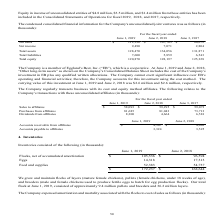According to Cal Maine Foods's financial document, What is the number of eggs in 2019? According to the financial document, 14,318 (in thousands). The relevant text states: "accumulated amortization $ 105,536 $ 96,594 Eggs 14,318 17,313 Feed and supplies 52,383 54,737 $ 172,237 $ 168,644..." Also, can you calculate: What is the increase / (decrease) in number of eggs in 2019? Based on the calculation: 14,318 - 17,313, the result is -2995 (in thousands). This is based on the information: "lated amortization $ 105,536 $ 96,594 Eggs 14,318 17,313 Feed and supplies 52,383 54,737 $ 172,237 $ 168,644 accumulated amortization $ 105,536 $ 96,594 Eggs 14,318 17,313 Feed and supplies 52,383 54,..." The key data points involved are: 14,318, 17,313. Also, What was the flock composition in June 2019? consisted of approximately 9.4 million pullets and breeders and 36.2 million layers.. The document states: "oduction flocks). Our total flock at June 1, 2019, consisted of approximately 9.4 million pullets and breeders and 36.2 million layers...." Also, What is the age for the pullets? According to the financial document, under 18 weeks. The relevant text states: "ature female chickens), pullets (female chickens, under 18 weeks of age), and breeders (male and female chickens used to produce fertile eggs to hatch for egg produ..." Also, can you calculate: What is the percentage increase / (decrease) in feed and supplies in 2019 compared to 2018? To answer this question, I need to perform calculations using the financial data. The calculation is: 52,383 / 54,737 - 1, which equals -4.3 (percentage). This is based on the information: "536 $ 96,594 Eggs 14,318 17,313 Feed and supplies 52,383 54,737 $ 172,237 $ 168,644 6,594 Eggs 14,318 17,313 Feed and supplies 52,383 54,737 $ 172,237 $ 168,644..." The key data points involved are: 52,383, 54,737. Also, can you calculate: What is the increase / (decrease) in total inventory in 2019 compared to 2018? Based on the calculation: 172,237 - 168,644, the result is 3593 (in thousands). This is based on the information: "7,313 Feed and supplies 52,383 54,737 $ 172,237 $ 168,644 s 14,318 17,313 Feed and supplies 52,383 54,737 $ 172,237 $ 168,644..." The key data points involved are: 168,644, 172,237. 